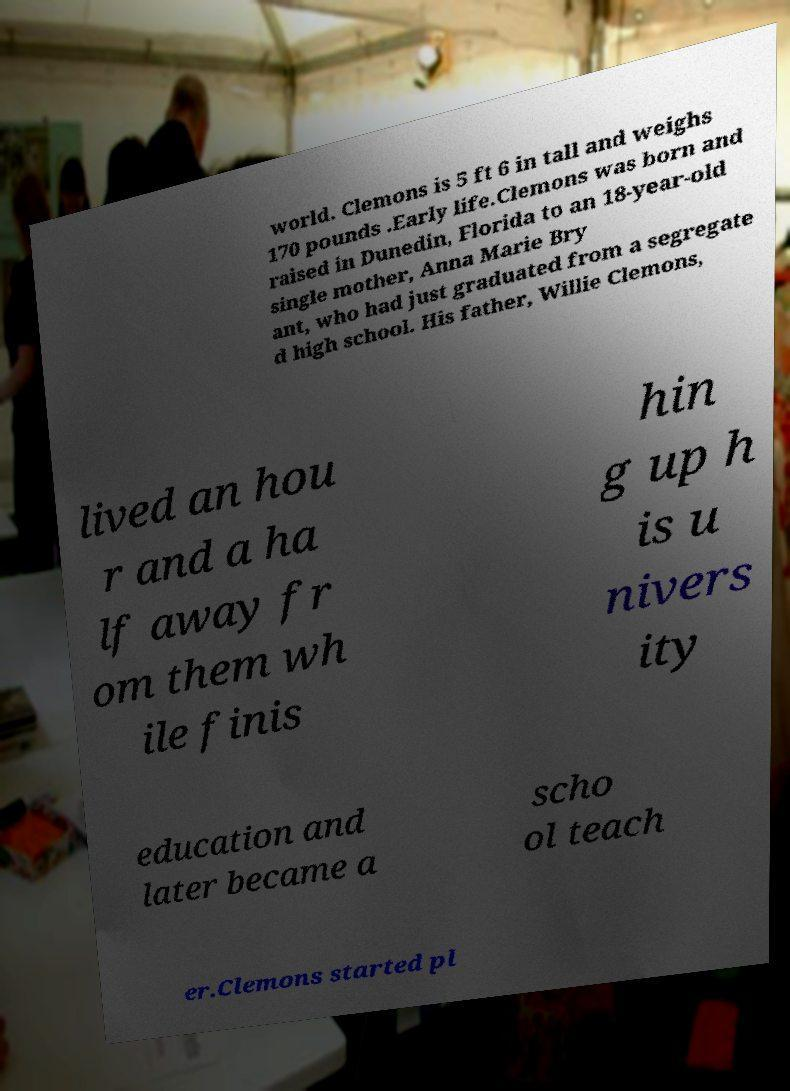There's text embedded in this image that I need extracted. Can you transcribe it verbatim? world. Clemons is 5 ft 6 in tall and weighs 170 pounds .Early life.Clemons was born and raised in Dunedin, Florida to an 18-year-old single mother, Anna Marie Bry ant, who had just graduated from a segregate d high school. His father, Willie Clemons, lived an hou r and a ha lf away fr om them wh ile finis hin g up h is u nivers ity education and later became a scho ol teach er.Clemons started pl 